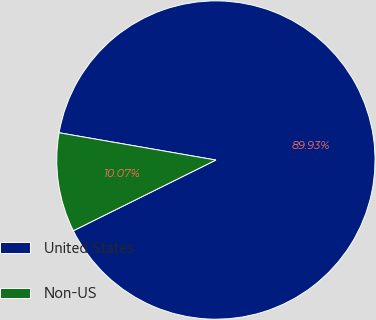<chart> <loc_0><loc_0><loc_500><loc_500><pie_chart><fcel>United States<fcel>Non-US<nl><fcel>89.93%<fcel>10.07%<nl></chart> 